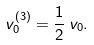Convert formula to latex. <formula><loc_0><loc_0><loc_500><loc_500>v ^ { ( 3 ) } _ { 0 } = \frac { 1 } { 2 } \, v _ { 0 } .</formula> 